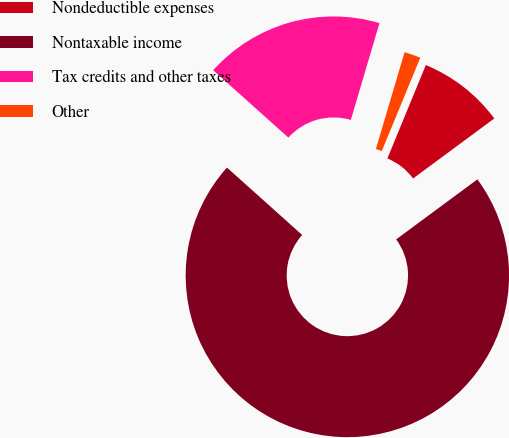Convert chart to OTSL. <chart><loc_0><loc_0><loc_500><loc_500><pie_chart><fcel>Nondeductible expenses<fcel>Nontaxable income<fcel>Tax credits and other taxes<fcel>Other<nl><fcel>8.65%<fcel>71.75%<fcel>17.95%<fcel>1.64%<nl></chart> 